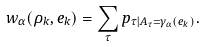Convert formula to latex. <formula><loc_0><loc_0><loc_500><loc_500>w _ { \alpha } ( \rho _ { k } , e _ { k } ) = \sum _ { \tau } p _ { \tau | A _ { \tau } = \gamma _ { \alpha } ( e _ { k } ) } .</formula> 